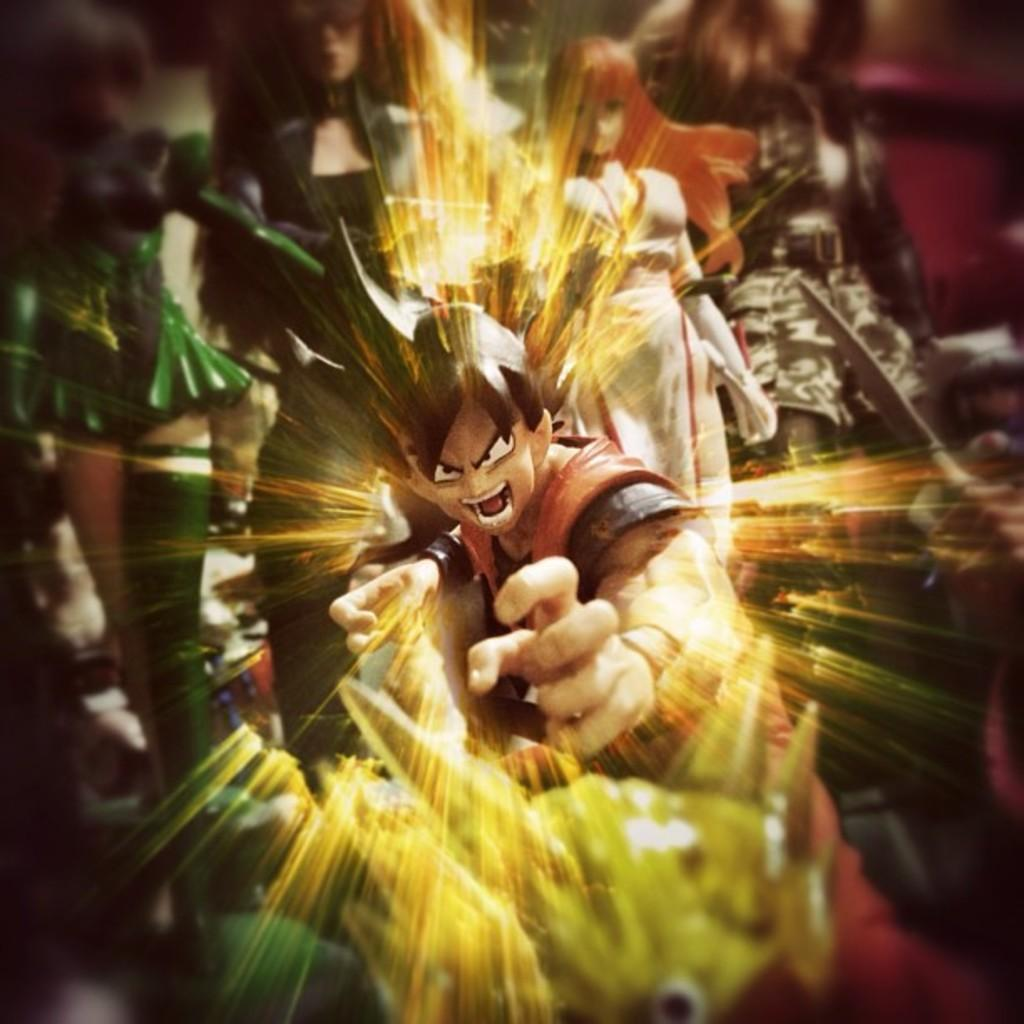What is the main subject of the image? The main subject of the image is a cartoon character with graphics. Are there any other cartoon characters in the image? Yes, there are other cartoon characters behind the main character. What month is depicted in the image? There is no month depicted in the image, as it features cartoon characters and not a calendar or any reference to a specific time. 